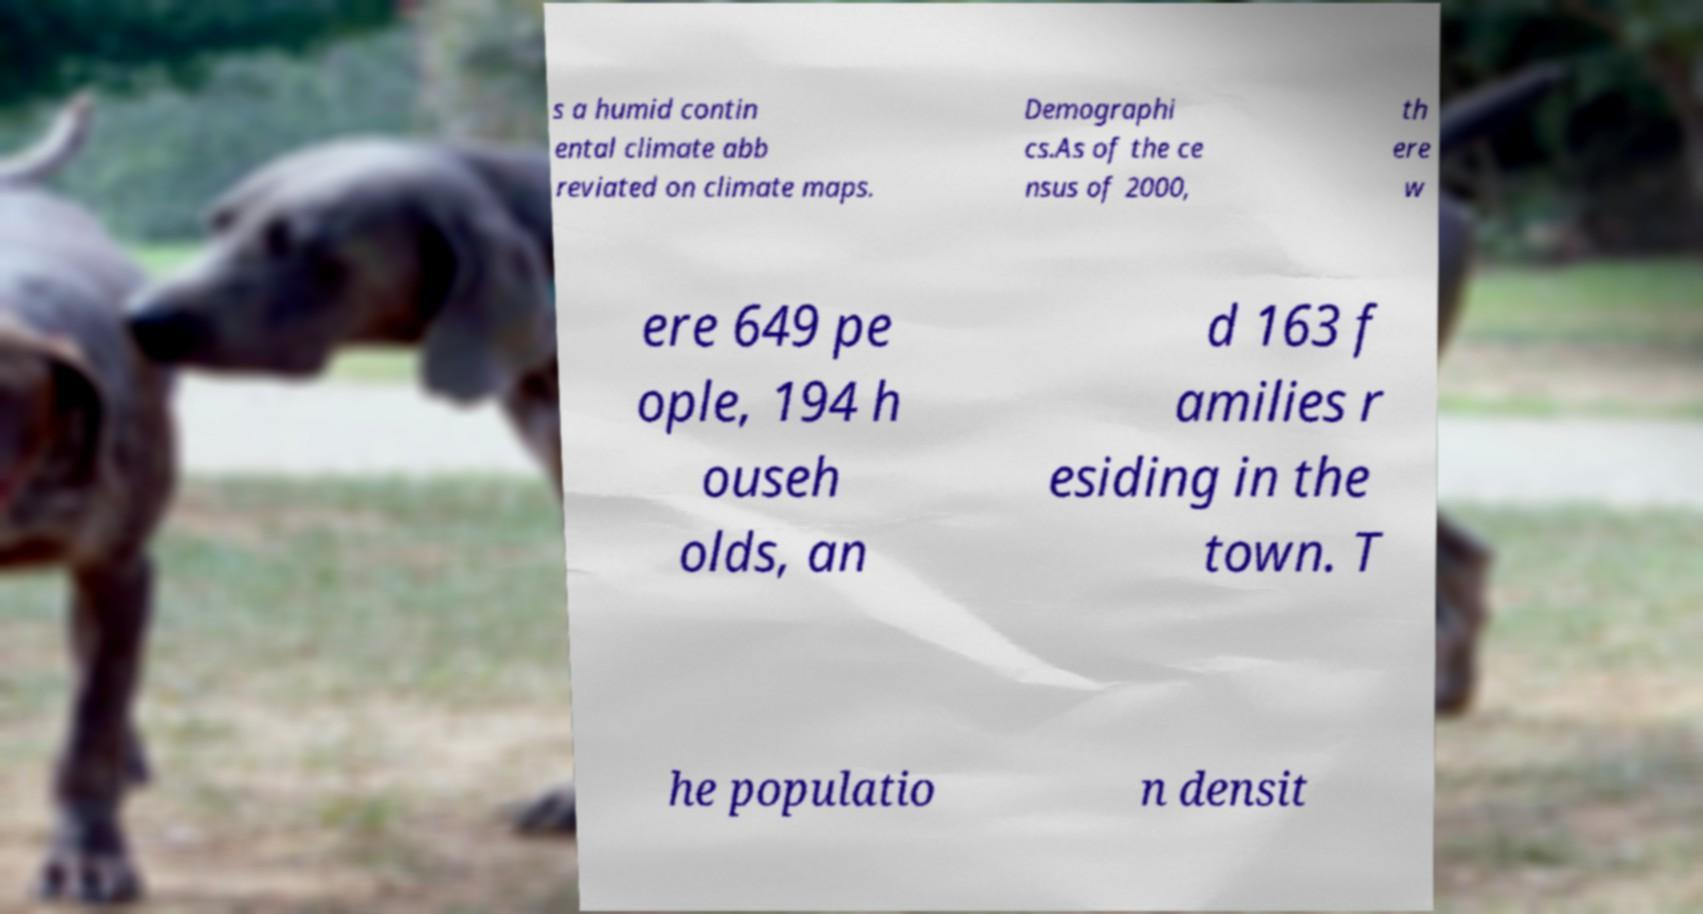Could you assist in decoding the text presented in this image and type it out clearly? s a humid contin ental climate abb reviated on climate maps. Demographi cs.As of the ce nsus of 2000, th ere w ere 649 pe ople, 194 h ouseh olds, an d 163 f amilies r esiding in the town. T he populatio n densit 